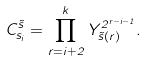<formula> <loc_0><loc_0><loc_500><loc_500>C ^ { \vec { s } } _ { s _ { i } } = \prod _ { r = i + 2 } ^ { k } Y _ { \vec { s } ( r ) } ^ { 2 ^ { r - i - 1 } } .</formula> 